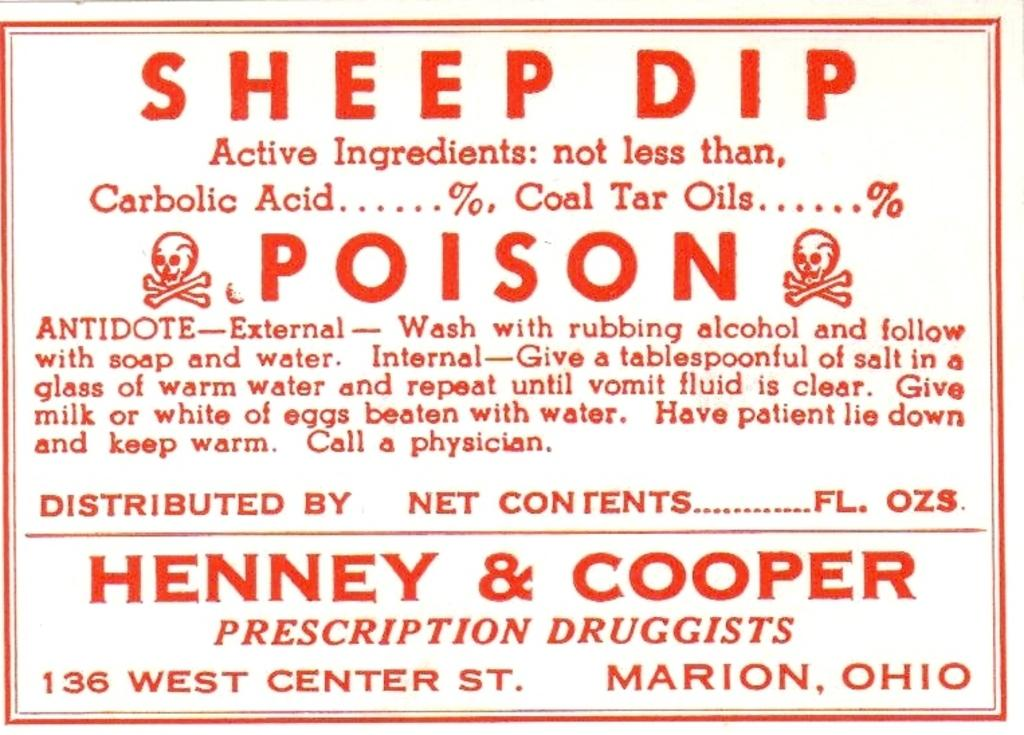<image>
Offer a succinct explanation of the picture presented. ad sign from henney and cooper about prescription drugs 